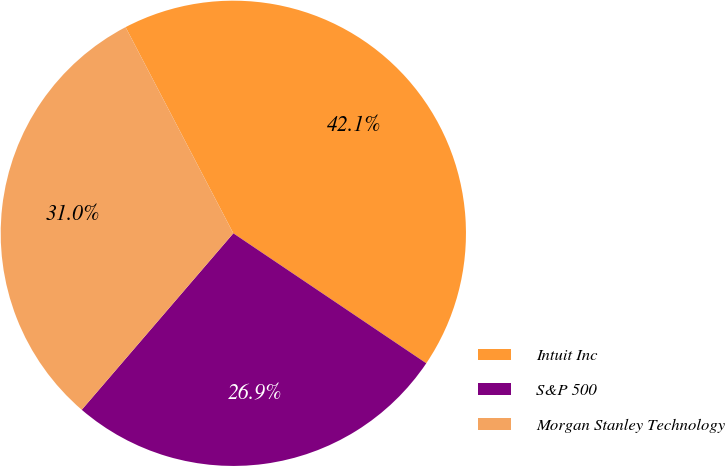Convert chart. <chart><loc_0><loc_0><loc_500><loc_500><pie_chart><fcel>Intuit Inc<fcel>S&P 500<fcel>Morgan Stanley Technology<nl><fcel>42.1%<fcel>26.86%<fcel>31.04%<nl></chart> 